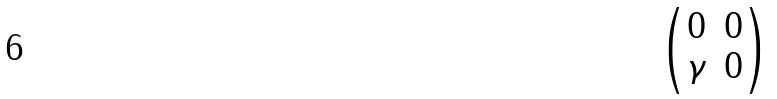<formula> <loc_0><loc_0><loc_500><loc_500>\begin{pmatrix} 0 & 0 \\ \gamma & 0 \end{pmatrix}</formula> 